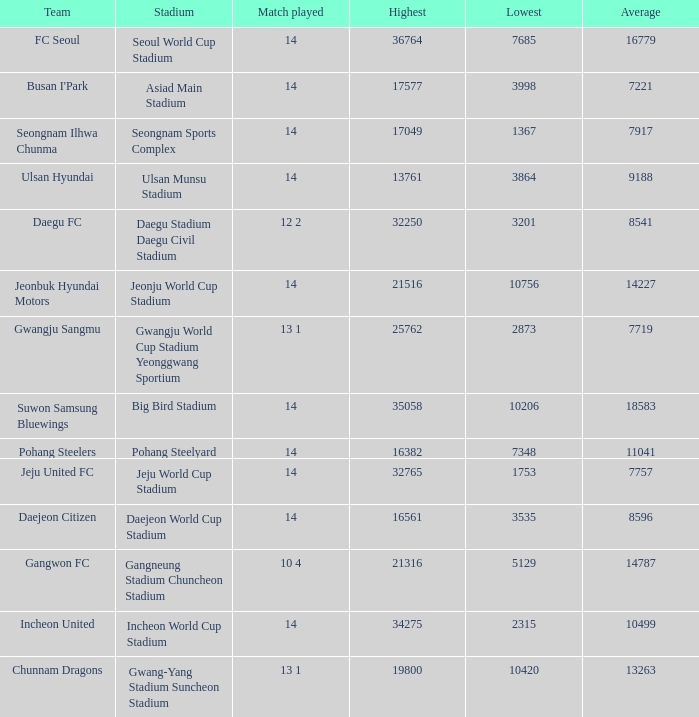Which team has a match played of 10 4? Gangwon FC. 